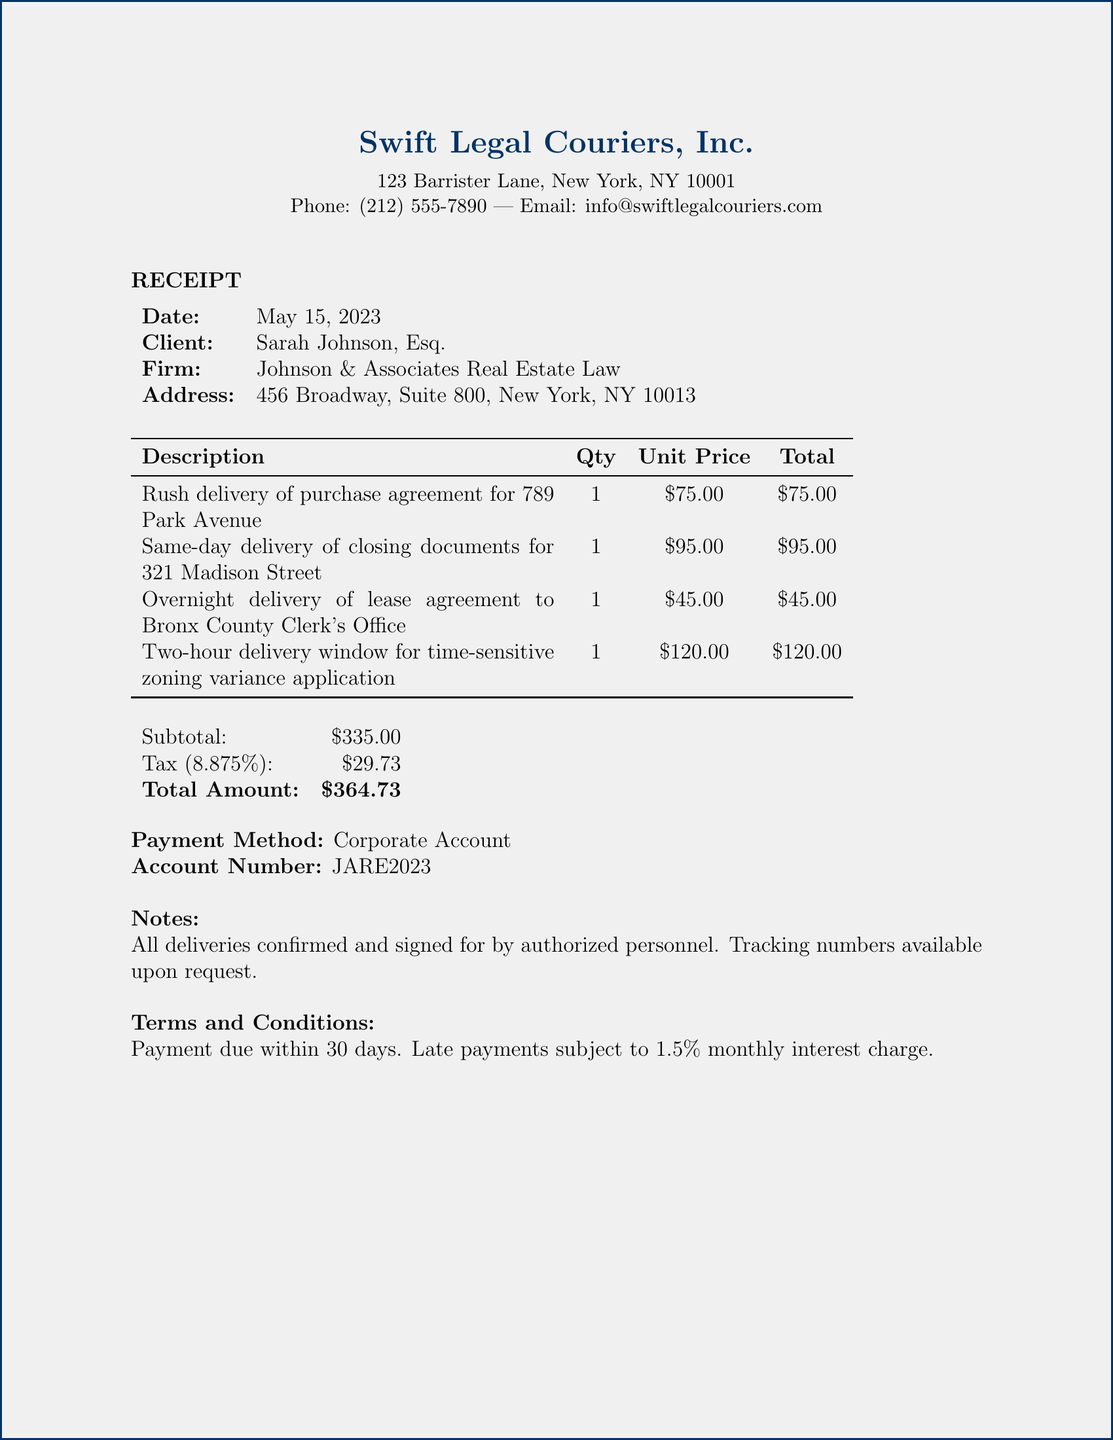What is the company name? The company name is Swift Legal Couriers, Inc. as listed at the top of the document.
Answer: Swift Legal Couriers, Inc What is the date of service? The date of service appears under the receipt header as May 15, 2023.
Answer: May 15, 2023 Who is the client? The client's name is included in the document under the client information section.
Answer: Sarah Johnson, Esq What is the total amount charged? The total amount is clearly stated in the financial summary section of the receipt.
Answer: $364.73 How many deliveries are listed? The number of deliveries can be counted from the services section of the document.
Answer: 4 What is the payment method used? The payment method is specified in the payment details section of the document.
Answer: Corporate Account What is the tax rate applied? The tax rate is mentioned alongside tax calculations in the subtotal section.
Answer: 8.875% What is the account number? The account number is given in the payment method section of the receipt.
Answer: JARE2023 What are the conditions regarding late payments? The terms and conditions section provides details on late payment consequences.
Answer: 1.5% monthly interest charge 